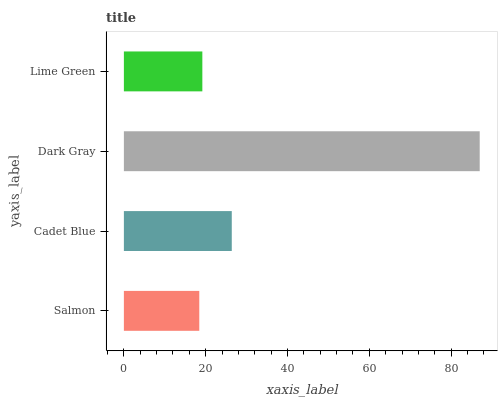Is Salmon the minimum?
Answer yes or no. Yes. Is Dark Gray the maximum?
Answer yes or no. Yes. Is Cadet Blue the minimum?
Answer yes or no. No. Is Cadet Blue the maximum?
Answer yes or no. No. Is Cadet Blue greater than Salmon?
Answer yes or no. Yes. Is Salmon less than Cadet Blue?
Answer yes or no. Yes. Is Salmon greater than Cadet Blue?
Answer yes or no. No. Is Cadet Blue less than Salmon?
Answer yes or no. No. Is Cadet Blue the high median?
Answer yes or no. Yes. Is Lime Green the low median?
Answer yes or no. Yes. Is Dark Gray the high median?
Answer yes or no. No. Is Cadet Blue the low median?
Answer yes or no. No. 